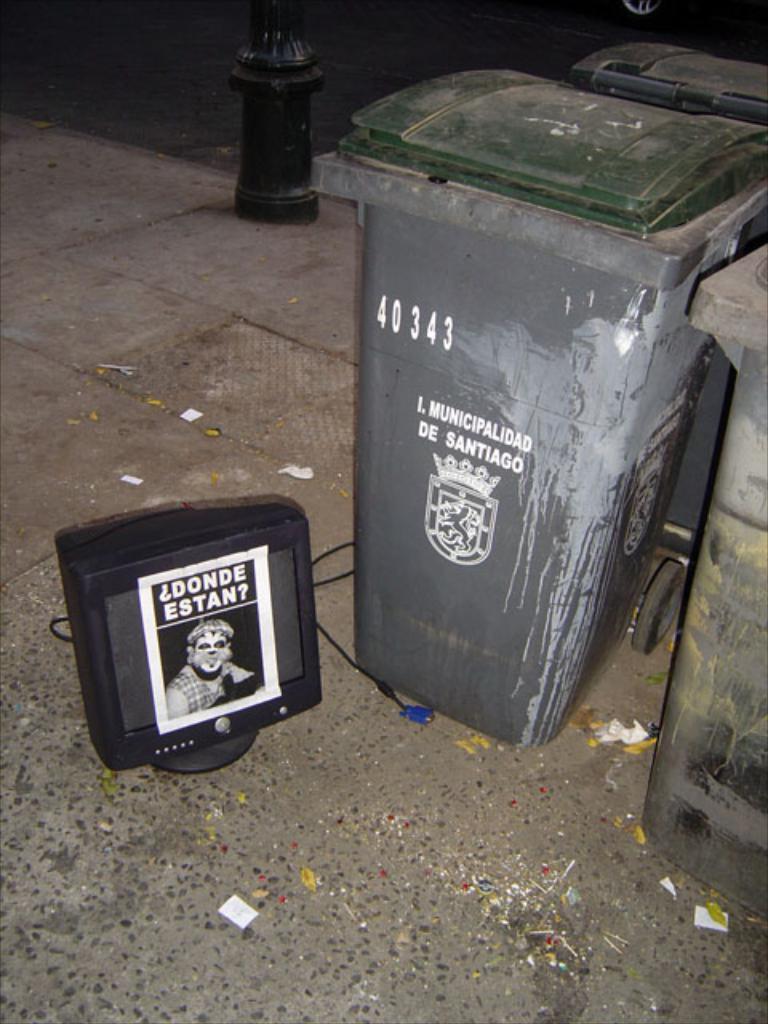What is the trash can number?
Make the answer very short. 40343. What city is this trash can in?
Make the answer very short. Santiago. 